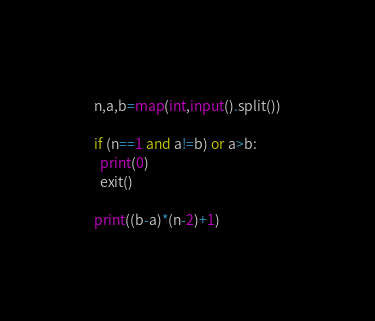<code> <loc_0><loc_0><loc_500><loc_500><_Python_>n,a,b=map(int,input().split())

if (n==1 and a!=b) or a>b:
  print(0)
  exit()
  
print((b-a)*(n-2)+1)
</code> 